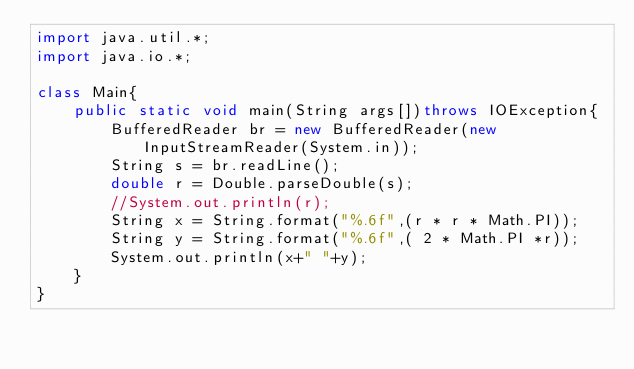<code> <loc_0><loc_0><loc_500><loc_500><_Java_>import java.util.*;
import java.io.*;

class Main{
    public static void main(String args[])throws IOException{
        BufferedReader br = new BufferedReader(new InputStreamReader(System.in));
        String s = br.readLine();
        double r = Double.parseDouble(s);
        //System.out.println(r);
        String x = String.format("%.6f",(r * r * Math.PI));
        String y = String.format("%.6f",( 2 * Math.PI *r));
        System.out.println(x+" "+y);
    }
}</code> 